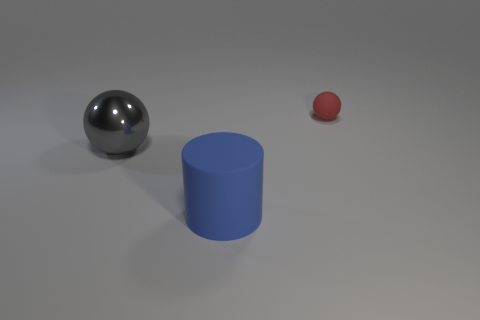There is a object that is behind the large object left of the object in front of the metal sphere; what size is it?
Ensure brevity in your answer.  Small. The large blue matte thing is what shape?
Provide a short and direct response. Cylinder. What number of large blue rubber cylinders are to the left of the rubber object behind the matte cylinder?
Give a very brief answer. 1. What number of other things are the same material as the small red object?
Provide a short and direct response. 1. Do the sphere that is to the right of the cylinder and the large object that is right of the large gray metal sphere have the same material?
Ensure brevity in your answer.  Yes. Are there any other things that have the same shape as the blue object?
Provide a short and direct response. No. Are the small red sphere and the large object right of the big gray thing made of the same material?
Provide a short and direct response. Yes. There is a sphere that is to the left of the rubber thing behind the rubber object that is left of the small matte ball; what color is it?
Offer a very short reply. Gray. There is a matte object that is the same size as the gray shiny sphere; what is its shape?
Your answer should be very brief. Cylinder. Is there any other thing that has the same size as the rubber cylinder?
Make the answer very short. Yes. 